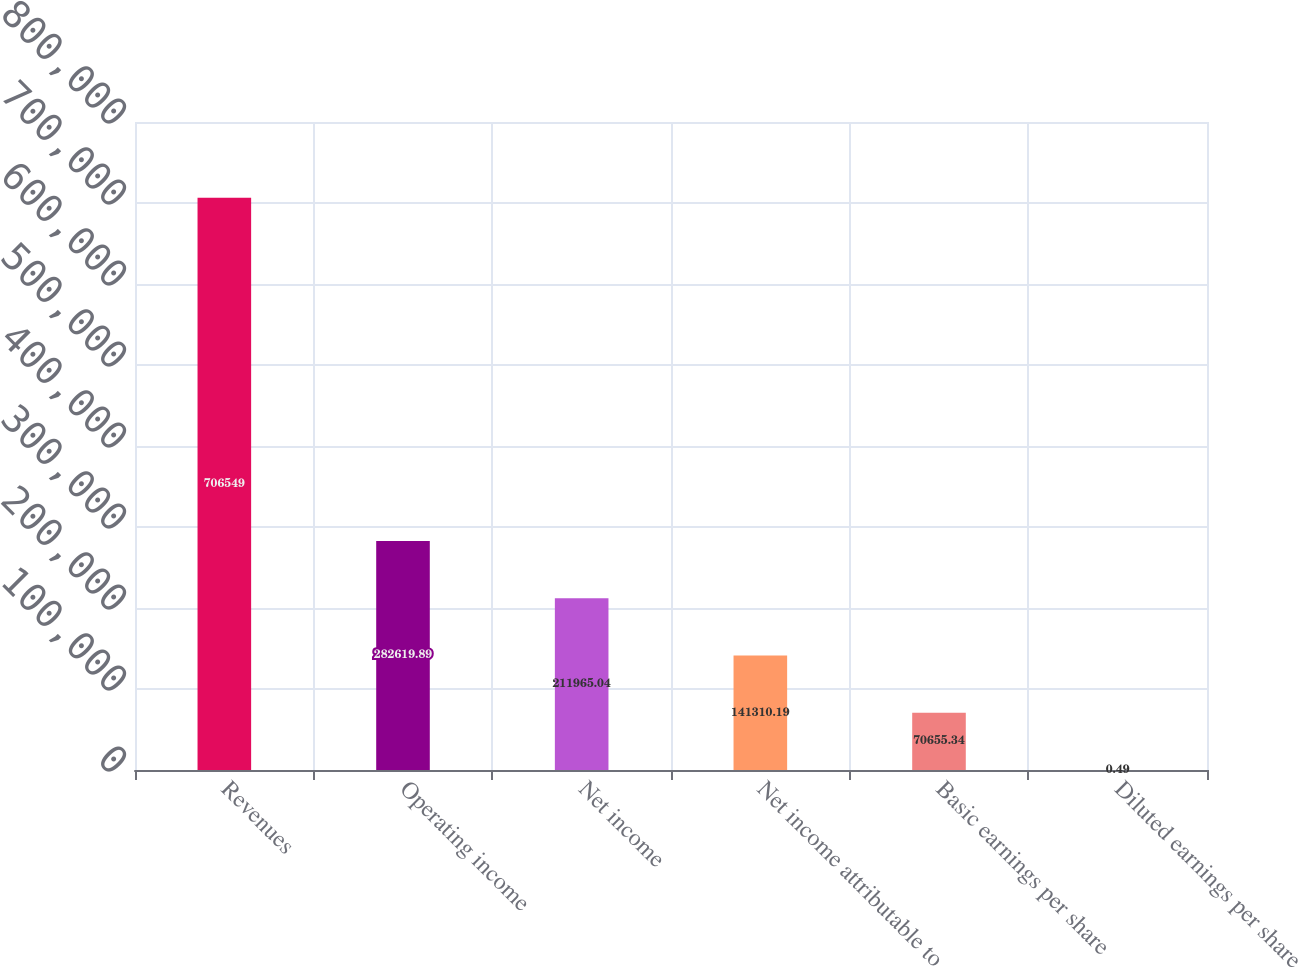Convert chart. <chart><loc_0><loc_0><loc_500><loc_500><bar_chart><fcel>Revenues<fcel>Operating income<fcel>Net income<fcel>Net income attributable to<fcel>Basic earnings per share<fcel>Diluted earnings per share<nl><fcel>706549<fcel>282620<fcel>211965<fcel>141310<fcel>70655.3<fcel>0.49<nl></chart> 